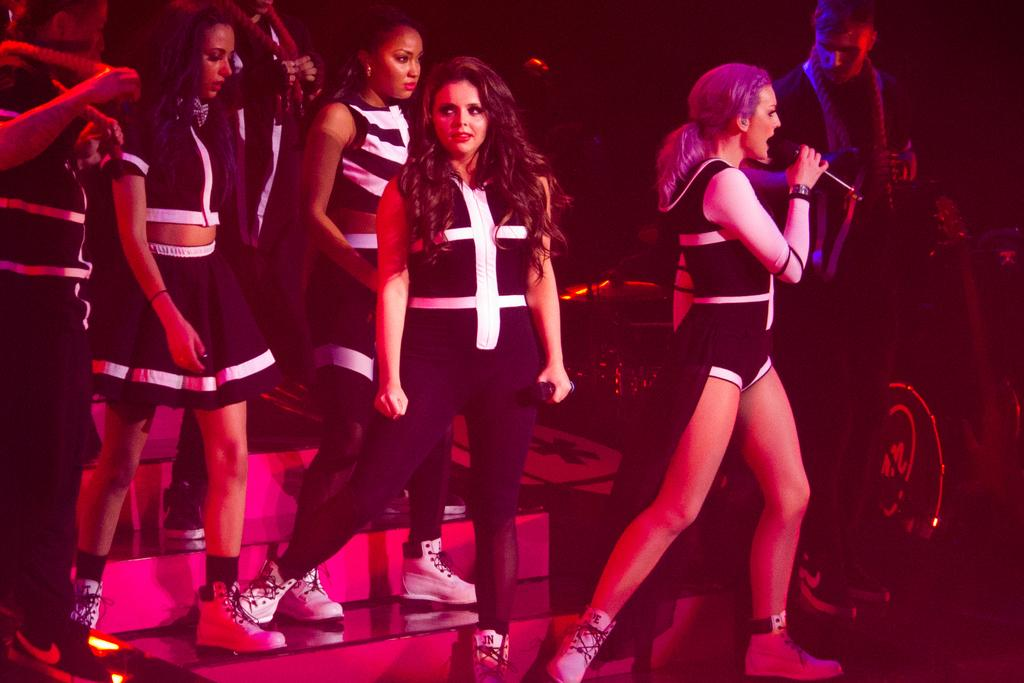What is happening in the image? There are people standing in the image, and a woman is holding a microphone in her hand. What is the woman doing with the microphone? The woman is singing. Are there any other people in the image besides the woman with the microphone? Yes, there are people standing on the side in the image. What language is the woman using to measure the board in the image? There is no board or measuring activity present in the image. The woman is singing, not measuring anything. 